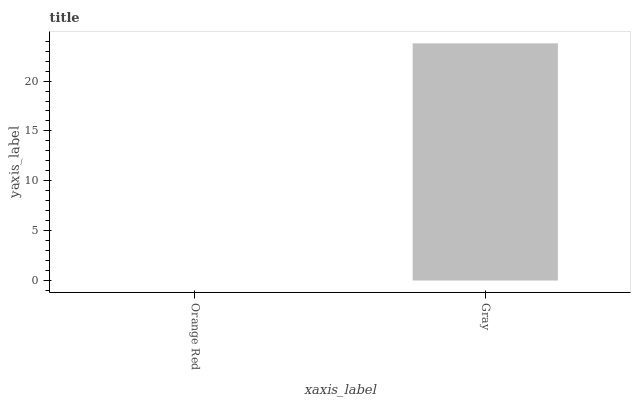Is Gray the minimum?
Answer yes or no. No. Is Gray greater than Orange Red?
Answer yes or no. Yes. Is Orange Red less than Gray?
Answer yes or no. Yes. Is Orange Red greater than Gray?
Answer yes or no. No. Is Gray less than Orange Red?
Answer yes or no. No. Is Gray the high median?
Answer yes or no. Yes. Is Orange Red the low median?
Answer yes or no. Yes. Is Orange Red the high median?
Answer yes or no. No. Is Gray the low median?
Answer yes or no. No. 